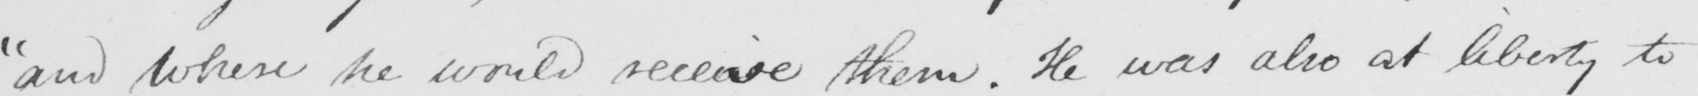Can you read and transcribe this handwriting? "and where he would receive them. He was also at liberty to 